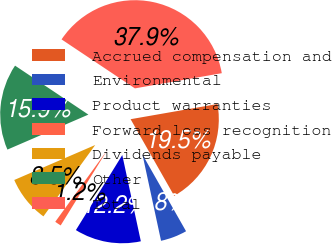Convert chart. <chart><loc_0><loc_0><loc_500><loc_500><pie_chart><fcel>Accrued compensation and<fcel>Environmental<fcel>Product warranties<fcel>Forward loss recognition<fcel>Dividends payable<fcel>Other<fcel>Total<nl><fcel>19.53%<fcel>4.85%<fcel>12.19%<fcel>1.18%<fcel>8.52%<fcel>15.86%<fcel>37.88%<nl></chart> 